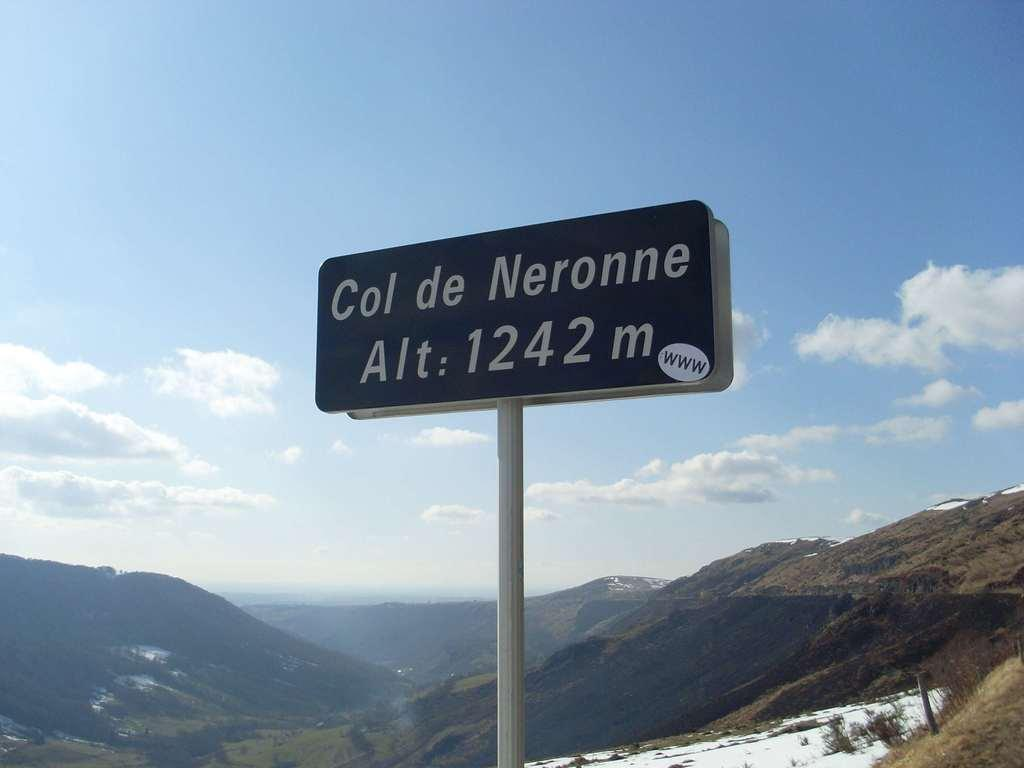<image>
Offer a succinct explanation of the picture presented. a sign for Col de Neronne in the middle of the mountains 